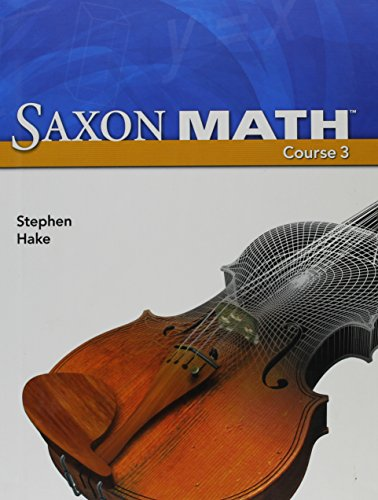Is this book related to Teen & Young Adult? Yes, 'Saxon Math Course 3' is targeted towards teenagers, particularly those in middle school, making it relevant to the Teen & Young Adult category in educational terms. 